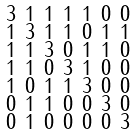<formula> <loc_0><loc_0><loc_500><loc_500>\begin{smallmatrix} 3 & 1 & 1 & 1 & 1 & 0 & 0 \\ 1 & 3 & 1 & 1 & 0 & 1 & 1 \\ 1 & 1 & 3 & 0 & 1 & 1 & 0 \\ 1 & 1 & 0 & 3 & 1 & 0 & 0 \\ 1 & 0 & 1 & 1 & 3 & 0 & 0 \\ 0 & 1 & 1 & 0 & 0 & 3 & 0 \\ 0 & 1 & 0 & 0 & 0 & 0 & 3 \end{smallmatrix}</formula> 